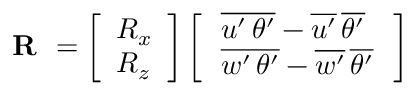<formula> <loc_0><loc_0><loc_500><loc_500>R = \left [ \begin{array} { l } { R _ { x } } \\ { R _ { z } } \end{array} \right ] \left [ \begin{array} { l } { \, \overline { { { u ^ { \prime } \, \theta ^ { \prime } } } } - \overline { { { u ^ { \prime } } } } \, \overline { { { \theta ^ { \prime } } } } \, } \\ { \, \overline { { { w ^ { \prime } \, \theta ^ { \prime } } } } - \overline { { { w ^ { \prime } } } } \, \overline { { { \theta ^ { \prime } } } } \, } \end{array} \right ]</formula> 